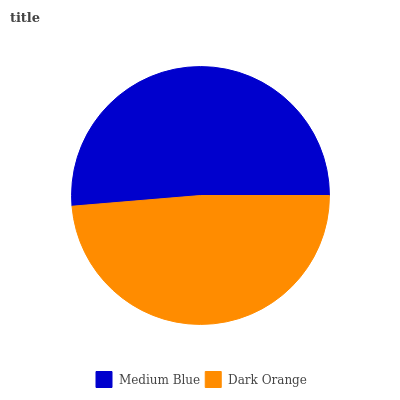Is Dark Orange the minimum?
Answer yes or no. Yes. Is Medium Blue the maximum?
Answer yes or no. Yes. Is Dark Orange the maximum?
Answer yes or no. No. Is Medium Blue greater than Dark Orange?
Answer yes or no. Yes. Is Dark Orange less than Medium Blue?
Answer yes or no. Yes. Is Dark Orange greater than Medium Blue?
Answer yes or no. No. Is Medium Blue less than Dark Orange?
Answer yes or no. No. Is Medium Blue the high median?
Answer yes or no. Yes. Is Dark Orange the low median?
Answer yes or no. Yes. Is Dark Orange the high median?
Answer yes or no. No. Is Medium Blue the low median?
Answer yes or no. No. 